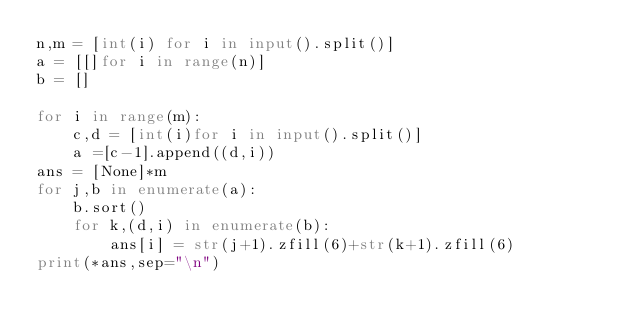<code> <loc_0><loc_0><loc_500><loc_500><_Python_>n,m = [int(i) for i in input().split()]
a = [[]for i in range(n)]
b = []

for i in range(m):
    c,d = [int(i)for i in input().split()]
    a =[c-1].append((d,i))
ans = [None]*m
for j,b in enumerate(a):
    b.sort()
    for k,(d,i) in enumerate(b):
        ans[i] = str(j+1).zfill(6)+str(k+1).zfill(6)
print(*ans,sep="\n")</code> 